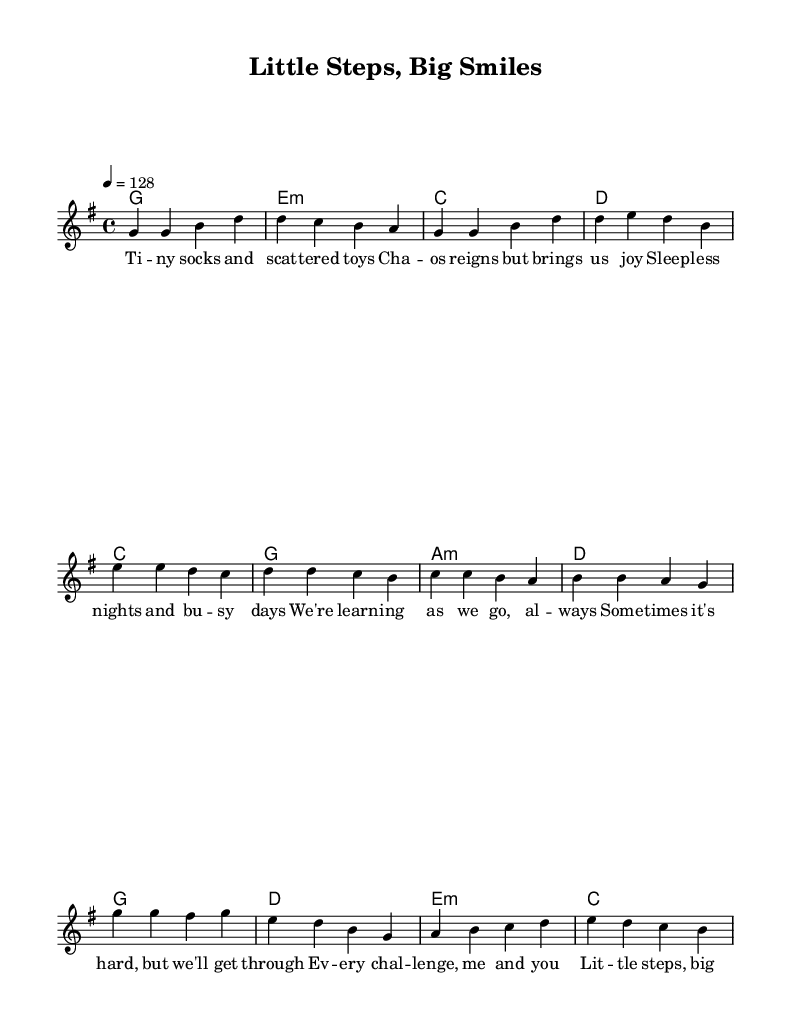What is the key signature of this music? The key signature is G major, which has one sharp (F#). You can identify this by looking at the beginning of the staff to find the sharp symbol.
Answer: G major What is the time signature of the piece? The time signature of this piece is 4/4, indicated at the beginning of the music. It shows that there are four beats in each measure and each quarter note gets one beat.
Answer: 4/4 What is the tempo marking of the music? The tempo marking is 128 beats per minute, specified at the beginning of the score. This provides a guideline for how fast the music should be played.
Answer: 128 How many measures are in the chorus? The chorus consists of four measures, which can be counted by looking at the section labeled "Chorus" and counting the vertical lines that indicate the ends of the measures.
Answer: 4 What is the primary theme of the lyrics in this song? The primary theme of the lyrics centers around overcoming challenges in parenting and celebrating small victories, as described in the lyrics. This thematic content is typical of K-Pop songs that resonate with young parents.
Answer: Overcoming challenges Which part of the music features the line "Little steps, big smiles"? The line "Little steps, big smiles" is featured in the chorus section. This is evident from referencing the specific lyrics associated with the chorus and noting their placement in the score.
Answer: Chorus What chord is used in the pre-chorus section? The chord used in the pre-chorus section is C major, identified by looking at the harmonies written above the corresponding lyrics for that section.
Answer: C 